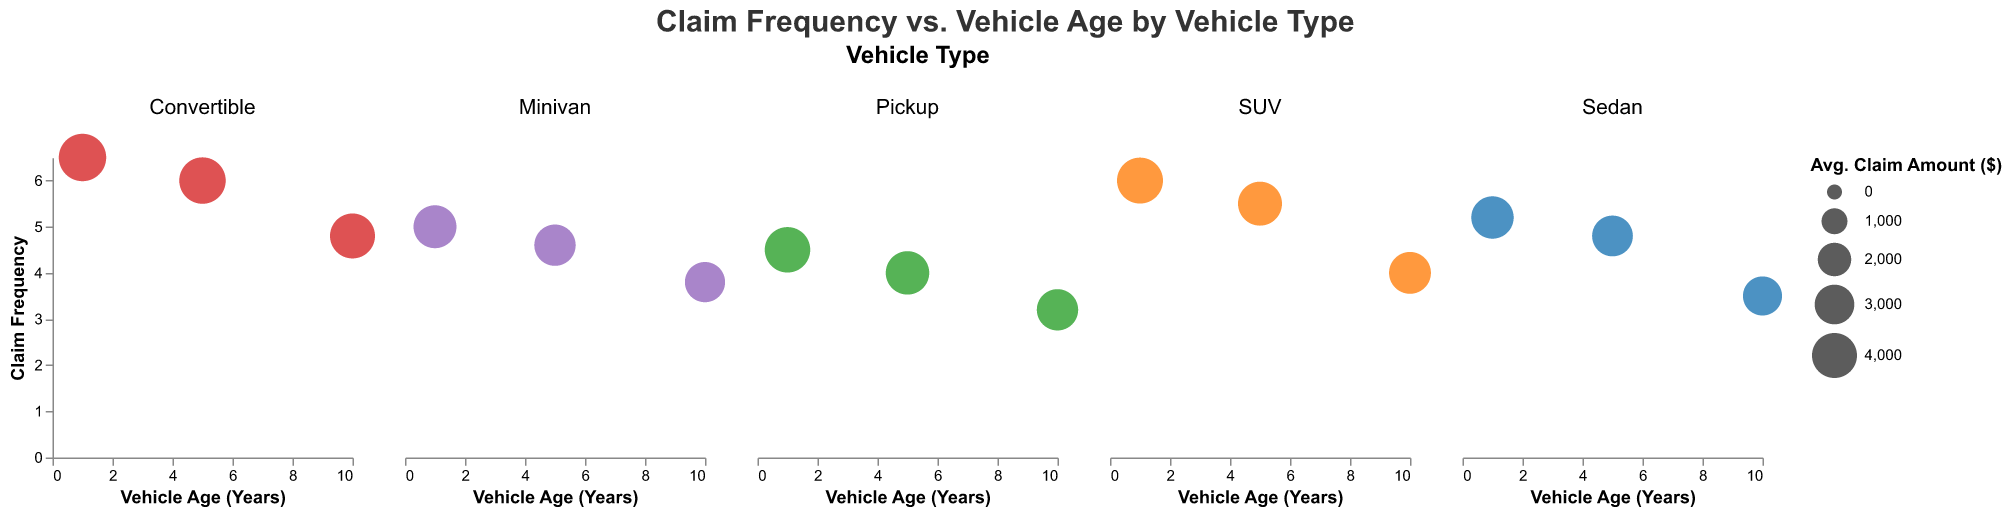What is the title of the chart? The title is typically at the top of the figure and labeled clearly. Here it is "Claim Frequency vs. Vehicle Age by Vehicle Type."
Answer: Claim Frequency vs. Vehicle Age by Vehicle Type Which vehicle type has the highest claim frequency at vehicle age 1? By observing the y-axis values of claim frequency for vehicle age 1 across all vehicle types, the highest point falls into the Convertible category, which has a claim frequency of 6.5.
Answer: Convertible As vehicle age increases, what happens to the claim frequency for SUVs? Look at the SUV subplot and check the trend of points from vehicle age 1 to 10 on the x-axis. It shows a decreasing pattern from 6.0 at age 1 to 4.0 at age 10.
Answer: Decreases What is the average claim frequency for Minivans across all vehicle ages? Identify Minivan subplot, find the claim frequencies for ages 1, 5, and 10 (5.0, 4.6, and 3.8, respectively), sum them up and divide by 3. \( \frac{5.0 + 4.6 + 3.8}{3} = 4.47 \)
Answer: 4.47 If you rank vehicle types by their average claim amount for 5-year-old vehicles, which vehicle type ranks first? Extract the average claim amounts for all vehicle types at age 5 (Sedan: 3200, SUV: 3800, Pickup: 3700, Convertible: 4300, Minivan: 3300), then identify the highest value. Convertible has the highest at 4300.
Answer: Convertible Which vehicle type has the most significant decrease in claim frequency between vehicle age 1 and vehicle age 10? Compare the decline in claim frequency from age 1 to age 10 for all types (Sedan: 5.2 to 3.5, SUV: 6.0 to 4.0, Pickup: 4.5 to 3.2, Convertible: 6.5 to 4.8, Minivan: 5.0 to 3.8). SUV shows the largest drop of 2.0 (6.0 - 4.0).
Answer: SUV Between Sedan and Pickup for age 5 vehicles, which has a higher claim frequency? Compare the y-axis values of claim frequency for Sedans (4.8) and Pickups (4.0) at vehicle age 5. Sedan has a higher value.
Answer: Sedan Which vehicle type at any age has the largest average claim amount visualized in the chart? Check the size of the bubbles which represent average claim amounts. The largest circle corresponds to Convertibles at vehicle age 1 with an average claim amount of $4,500.
Answer: Convertible at vehicle age 1 